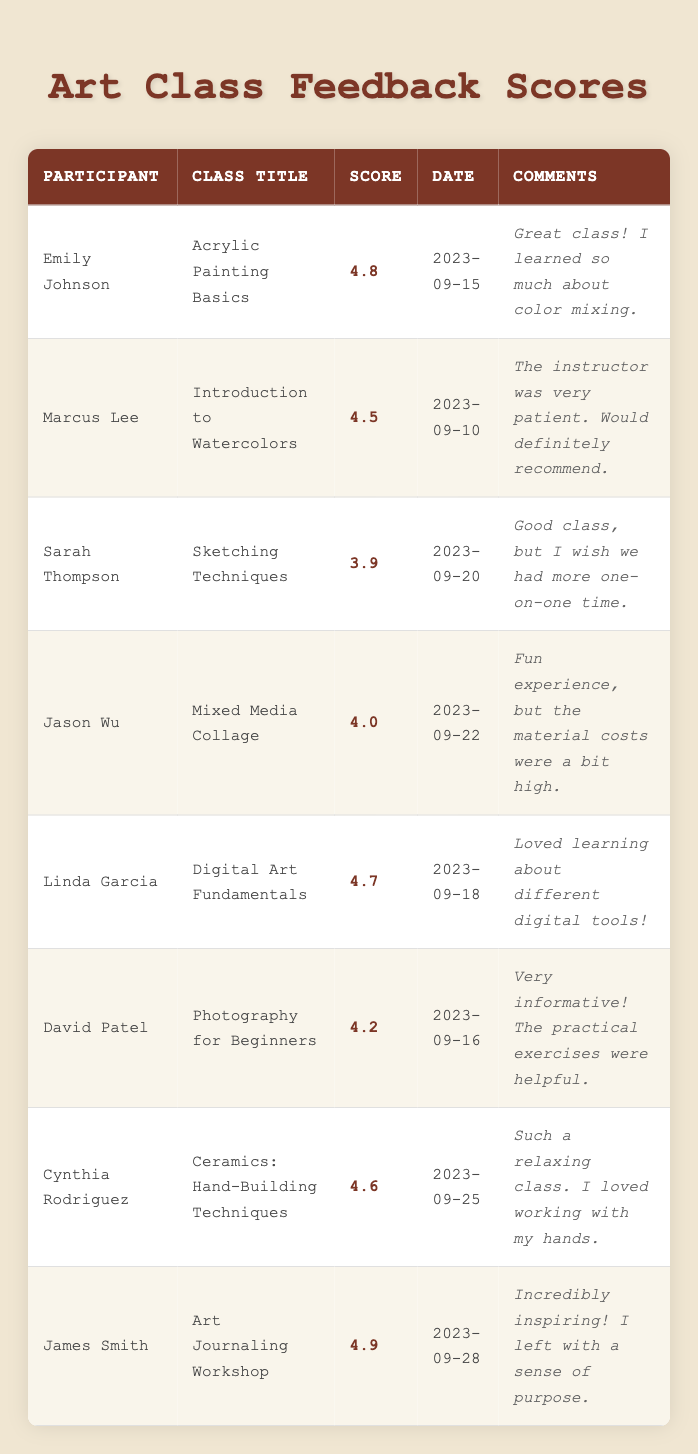What is the highest feedback score in the table? The table lists all feedback scores, and after reviewing them, I can see that the highest score is 4.9, given by James Smith for the Art Journaling Workshop.
Answer: 4.9 Who gave the lowest score and what was it? The lowest score in the table is 3.9, provided by Sarah Thompson for the class "Sketching Techniques."
Answer: Sarah Thompson, 3.9 How many participants scored above 4.5? By counting the scores in the table, I find that five participants received scores higher than 4.5: Emily Johnson (4.8), Linda Garcia (4.7), Cynthia Rodriguez (4.6), David Patel (4.2), and James Smith (4.9).
Answer: 5 What is the average score of all the feedback scores provided? To find the average score, I need to sum all the scores: 4.8 + 4.5 + 3.9 + 4.0 + 4.7 + 4.2 + 4.6 + 4.9 = 36.6. Then, I divide by the number of participants, which is 8. Therefore, the average score is 36.6 / 8 = 4.575.
Answer: 4.575 Was any participant dissatisfied with their class experience? The comment from Sarah Thompson indicates some dissatisfaction as she mentioned wishing for more one-on-one time, which can imply that she was not fully satisfied with the class.
Answer: Yes Which class had the highest score and what was the score? Examining the scores, I see that James Smith's "Art Journaling Workshop" received the highest score of 4.9.
Answer: Art Journaling Workshop, 4.9 How many classes received scores of 4.5 or higher? The classes with scores of 4.5 or higher are Acrylic Painting Basics, Introduction to Watercolors, Digital Art Fundamentals, Ceramics: Hand-Building Techniques, and Art Journaling Workshop. This gives a total of 5 classes.
Answer: 5 What percentage of participants rated the classes with a score less than 4? Only one participant, Sarah Thompson, rated her class below 4 (with a score of 3.9), out of a total of 8 participants. Therefore, the percentage is (1/8) * 100 = 12.5%.
Answer: 12.5% 